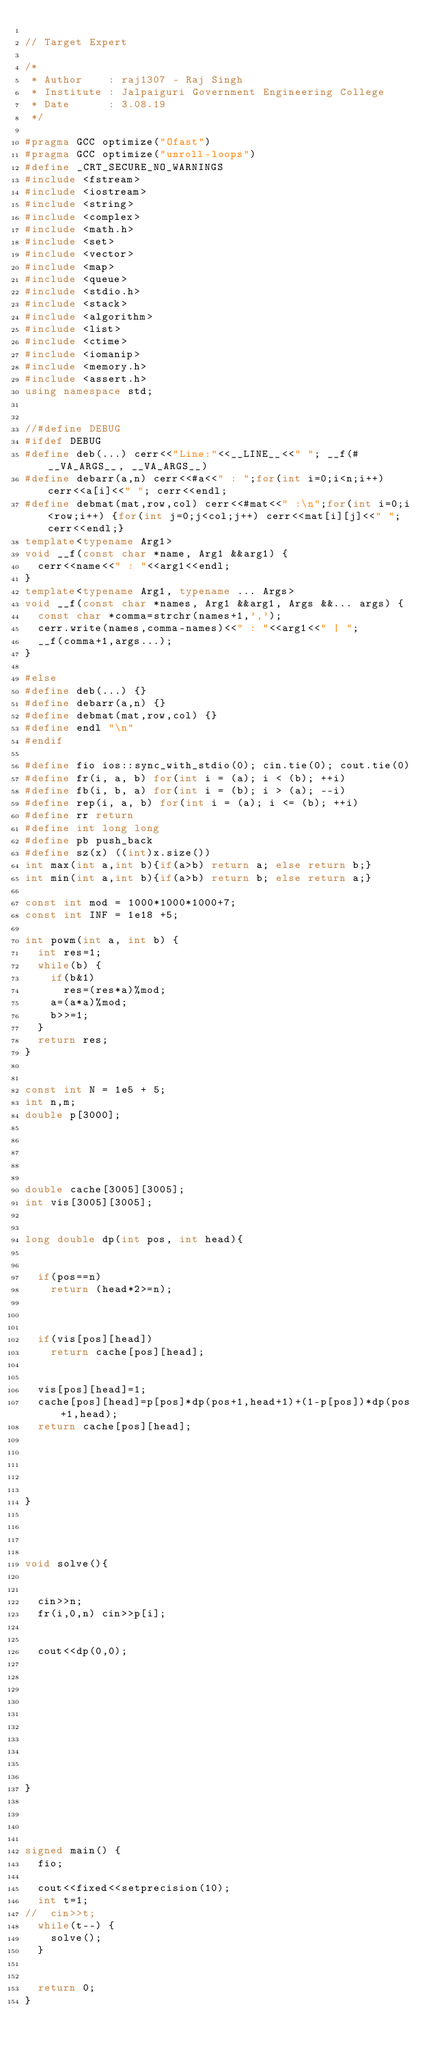<code> <loc_0><loc_0><loc_500><loc_500><_C++_>
// Target Expert 

/*
 * Author    : raj1307 - Raj Singh
 * Institute : Jalpaiguri Government Engineering College
 * Date      : 3.08.19
 */

#pragma GCC optimize("Ofast")
#pragma GCC optimize("unroll-loops")
#define _CRT_SECURE_NO_WARNINGS
#include <fstream>
#include <iostream>
#include <string>
#include <complex>
#include <math.h>
#include <set>
#include <vector>
#include <map>
#include <queue>
#include <stdio.h>
#include <stack>
#include <algorithm>
#include <list>
#include <ctime>
#include <iomanip>
#include <memory.h>
#include <assert.h>
using namespace std;


//#define DEBUG
#ifdef DEBUG
#define deb(...) cerr<<"Line:"<<__LINE__<<" "; __f(#__VA_ARGS__, __VA_ARGS__)
#define debarr(a,n) cerr<<#a<<" : ";for(int i=0;i<n;i++) cerr<<a[i]<<" "; cerr<<endl;
#define debmat(mat,row,col) cerr<<#mat<<" :\n";for(int i=0;i<row;i++) {for(int j=0;j<col;j++) cerr<<mat[i][j]<<" ";cerr<<endl;}
template<typename Arg1>
void __f(const char *name, Arg1 &&arg1) {
	cerr<<name<<" : "<<arg1<<endl;
}
template<typename Arg1, typename ... Args>
void __f(const char *names, Arg1 &&arg1, Args &&... args) {
	const char *comma=strchr(names+1,',');
	cerr.write(names,comma-names)<<" : "<<arg1<<" | ";
	__f(comma+1,args...);
}

#else
#define deb(...) {}
#define debarr(a,n) {}
#define debmat(mat,row,col) {}
#define endl "\n"
#endif

#define fio ios::sync_with_stdio(0); cin.tie(0); cout.tie(0)
#define fr(i, a, b) for(int i = (a); i < (b); ++i)
#define fb(i, b, a) for(int i = (b); i > (a); --i)
#define rep(i, a, b) for(int i = (a); i <= (b); ++i)
#define rr return 
#define int long long
#define pb push_back
#define sz(x) ((int)x.size())
int max(int a,int b){if(a>b) return a; else return b;}
int min(int a,int b){if(a>b) return b; else return a;}

const int mod = 1000*1000*1000+7;
const int INF = 1e18 +5;

int powm(int a, int b) {
	int res=1;
	while(b) {
		if(b&1)
			res=(res*a)%mod;
		a=(a*a)%mod;
		b>>=1;
	}
	return res;
}


const int N = 1e5 + 5;
int n,m;
double p[3000];


 


double cache[3005][3005];
int vis[3005][3005];


long double dp(int pos, int head){


	if(pos==n)
		return (head*2>=n);



	if(vis[pos][head])
		return cache[pos][head];


	vis[pos][head]=1;
	cache[pos][head]=p[pos]*dp(pos+1,head+1)+(1-p[pos])*dp(pos+1,head);
	return cache[pos][head];





}



 
void solve(){
 
 
	cin>>n;
	fr(i,0,n) cin>>p[i];


	cout<<dp(0,0);









 
}
 



signed main() {
	fio;
	
	cout<<fixed<<setprecision(10);
	int t=1;
//	cin>>t;
	while(t--) {
		solve();
	}

	
	return 0;
}
</code> 